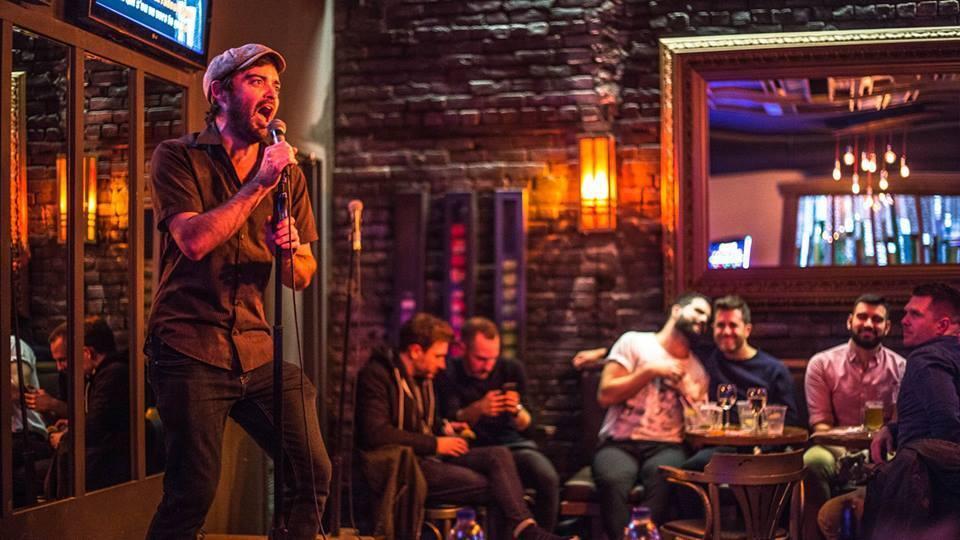Can you speculate on the topics of conversation among the group at the table? Given the jovial scene and casual setting, their conversation might revolve around shared experiences, personal anecdotes, or comments about the performer's act. They may also be exchanging jokes or discussing other aspects of their day, which are typical in such a social setting where people come to unwind and enjoy. 